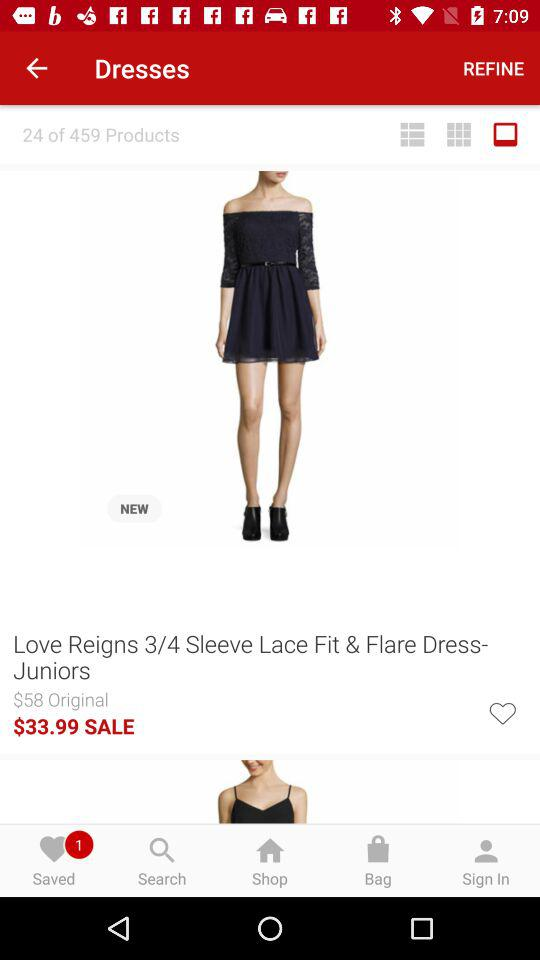What is the sale price after the discount? The sale price after the discount is $33.99. 